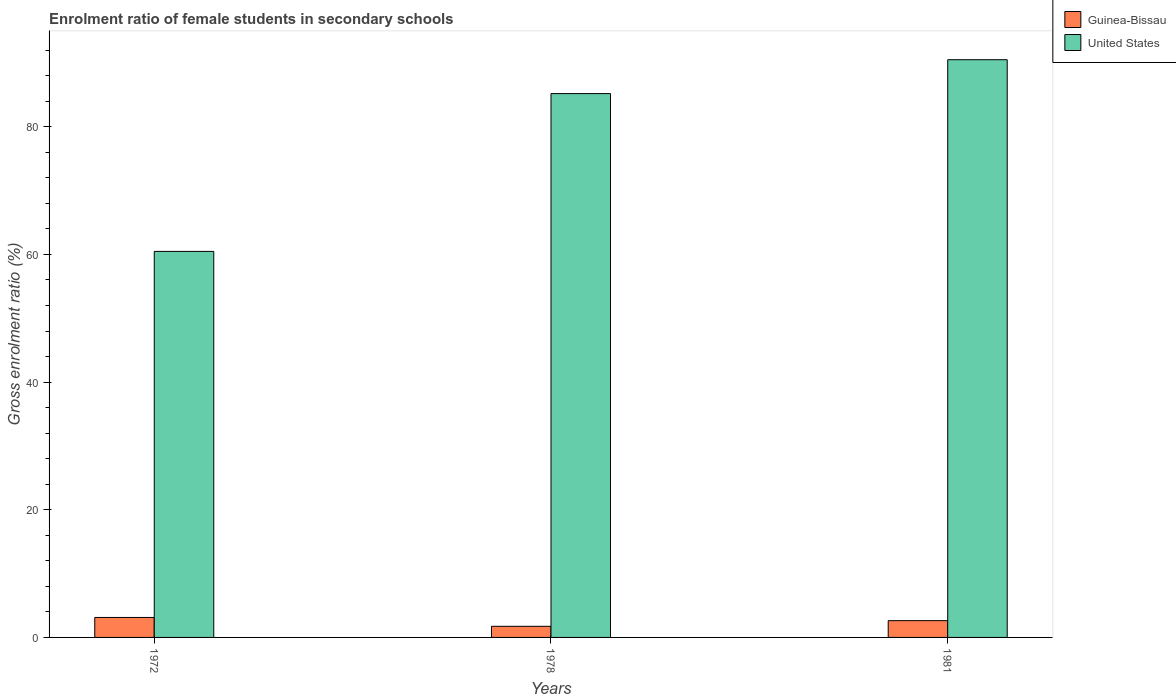How many groups of bars are there?
Give a very brief answer. 3. Are the number of bars per tick equal to the number of legend labels?
Give a very brief answer. Yes. What is the label of the 1st group of bars from the left?
Your answer should be very brief. 1972. In how many cases, is the number of bars for a given year not equal to the number of legend labels?
Your answer should be compact. 0. What is the enrolment ratio of female students in secondary schools in United States in 1972?
Provide a short and direct response. 60.48. Across all years, what is the maximum enrolment ratio of female students in secondary schools in United States?
Your answer should be compact. 90.51. Across all years, what is the minimum enrolment ratio of female students in secondary schools in Guinea-Bissau?
Provide a short and direct response. 1.74. In which year was the enrolment ratio of female students in secondary schools in United States maximum?
Your response must be concise. 1981. What is the total enrolment ratio of female students in secondary schools in Guinea-Bissau in the graph?
Make the answer very short. 7.5. What is the difference between the enrolment ratio of female students in secondary schools in United States in 1972 and that in 1981?
Offer a terse response. -30.03. What is the difference between the enrolment ratio of female students in secondary schools in Guinea-Bissau in 1981 and the enrolment ratio of female students in secondary schools in United States in 1978?
Your response must be concise. -82.57. What is the average enrolment ratio of female students in secondary schools in United States per year?
Provide a succinct answer. 78.73. In the year 1978, what is the difference between the enrolment ratio of female students in secondary schools in Guinea-Bissau and enrolment ratio of female students in secondary schools in United States?
Keep it short and to the point. -83.45. In how many years, is the enrolment ratio of female students in secondary schools in Guinea-Bissau greater than 84 %?
Provide a succinct answer. 0. What is the ratio of the enrolment ratio of female students in secondary schools in Guinea-Bissau in 1978 to that in 1981?
Give a very brief answer. 0.66. What is the difference between the highest and the second highest enrolment ratio of female students in secondary schools in United States?
Your answer should be very brief. 5.31. What is the difference between the highest and the lowest enrolment ratio of female students in secondary schools in United States?
Your answer should be very brief. 30.03. What does the 1st bar from the left in 1978 represents?
Ensure brevity in your answer.  Guinea-Bissau. Are all the bars in the graph horizontal?
Ensure brevity in your answer.  No. Does the graph contain grids?
Offer a very short reply. No. What is the title of the graph?
Give a very brief answer. Enrolment ratio of female students in secondary schools. What is the label or title of the X-axis?
Make the answer very short. Years. What is the label or title of the Y-axis?
Keep it short and to the point. Gross enrolment ratio (%). What is the Gross enrolment ratio (%) of Guinea-Bissau in 1972?
Keep it short and to the point. 3.13. What is the Gross enrolment ratio (%) in United States in 1972?
Keep it short and to the point. 60.48. What is the Gross enrolment ratio (%) in Guinea-Bissau in 1978?
Make the answer very short. 1.74. What is the Gross enrolment ratio (%) in United States in 1978?
Provide a short and direct response. 85.2. What is the Gross enrolment ratio (%) in Guinea-Bissau in 1981?
Keep it short and to the point. 2.63. What is the Gross enrolment ratio (%) in United States in 1981?
Ensure brevity in your answer.  90.51. Across all years, what is the maximum Gross enrolment ratio (%) of Guinea-Bissau?
Your answer should be very brief. 3.13. Across all years, what is the maximum Gross enrolment ratio (%) in United States?
Offer a very short reply. 90.51. Across all years, what is the minimum Gross enrolment ratio (%) of Guinea-Bissau?
Your answer should be very brief. 1.74. Across all years, what is the minimum Gross enrolment ratio (%) of United States?
Make the answer very short. 60.48. What is the total Gross enrolment ratio (%) in Guinea-Bissau in the graph?
Give a very brief answer. 7.5. What is the total Gross enrolment ratio (%) of United States in the graph?
Offer a very short reply. 236.18. What is the difference between the Gross enrolment ratio (%) in Guinea-Bissau in 1972 and that in 1978?
Make the answer very short. 1.38. What is the difference between the Gross enrolment ratio (%) of United States in 1972 and that in 1978?
Make the answer very short. -24.72. What is the difference between the Gross enrolment ratio (%) in Guinea-Bissau in 1972 and that in 1981?
Your response must be concise. 0.5. What is the difference between the Gross enrolment ratio (%) in United States in 1972 and that in 1981?
Your response must be concise. -30.03. What is the difference between the Gross enrolment ratio (%) in Guinea-Bissau in 1978 and that in 1981?
Give a very brief answer. -0.88. What is the difference between the Gross enrolment ratio (%) in United States in 1978 and that in 1981?
Provide a succinct answer. -5.31. What is the difference between the Gross enrolment ratio (%) in Guinea-Bissau in 1972 and the Gross enrolment ratio (%) in United States in 1978?
Keep it short and to the point. -82.07. What is the difference between the Gross enrolment ratio (%) of Guinea-Bissau in 1972 and the Gross enrolment ratio (%) of United States in 1981?
Your response must be concise. -87.38. What is the difference between the Gross enrolment ratio (%) in Guinea-Bissau in 1978 and the Gross enrolment ratio (%) in United States in 1981?
Give a very brief answer. -88.76. What is the average Gross enrolment ratio (%) of Guinea-Bissau per year?
Give a very brief answer. 2.5. What is the average Gross enrolment ratio (%) in United States per year?
Keep it short and to the point. 78.73. In the year 1972, what is the difference between the Gross enrolment ratio (%) of Guinea-Bissau and Gross enrolment ratio (%) of United States?
Offer a terse response. -57.35. In the year 1978, what is the difference between the Gross enrolment ratio (%) in Guinea-Bissau and Gross enrolment ratio (%) in United States?
Offer a very short reply. -83.45. In the year 1981, what is the difference between the Gross enrolment ratio (%) of Guinea-Bissau and Gross enrolment ratio (%) of United States?
Provide a succinct answer. -87.88. What is the ratio of the Gross enrolment ratio (%) in Guinea-Bissau in 1972 to that in 1978?
Provide a succinct answer. 1.79. What is the ratio of the Gross enrolment ratio (%) of United States in 1972 to that in 1978?
Keep it short and to the point. 0.71. What is the ratio of the Gross enrolment ratio (%) of Guinea-Bissau in 1972 to that in 1981?
Your response must be concise. 1.19. What is the ratio of the Gross enrolment ratio (%) in United States in 1972 to that in 1981?
Your answer should be very brief. 0.67. What is the ratio of the Gross enrolment ratio (%) in Guinea-Bissau in 1978 to that in 1981?
Provide a short and direct response. 0.66. What is the ratio of the Gross enrolment ratio (%) of United States in 1978 to that in 1981?
Provide a short and direct response. 0.94. What is the difference between the highest and the second highest Gross enrolment ratio (%) in Guinea-Bissau?
Provide a short and direct response. 0.5. What is the difference between the highest and the second highest Gross enrolment ratio (%) in United States?
Your answer should be very brief. 5.31. What is the difference between the highest and the lowest Gross enrolment ratio (%) in Guinea-Bissau?
Offer a very short reply. 1.38. What is the difference between the highest and the lowest Gross enrolment ratio (%) of United States?
Your answer should be very brief. 30.03. 